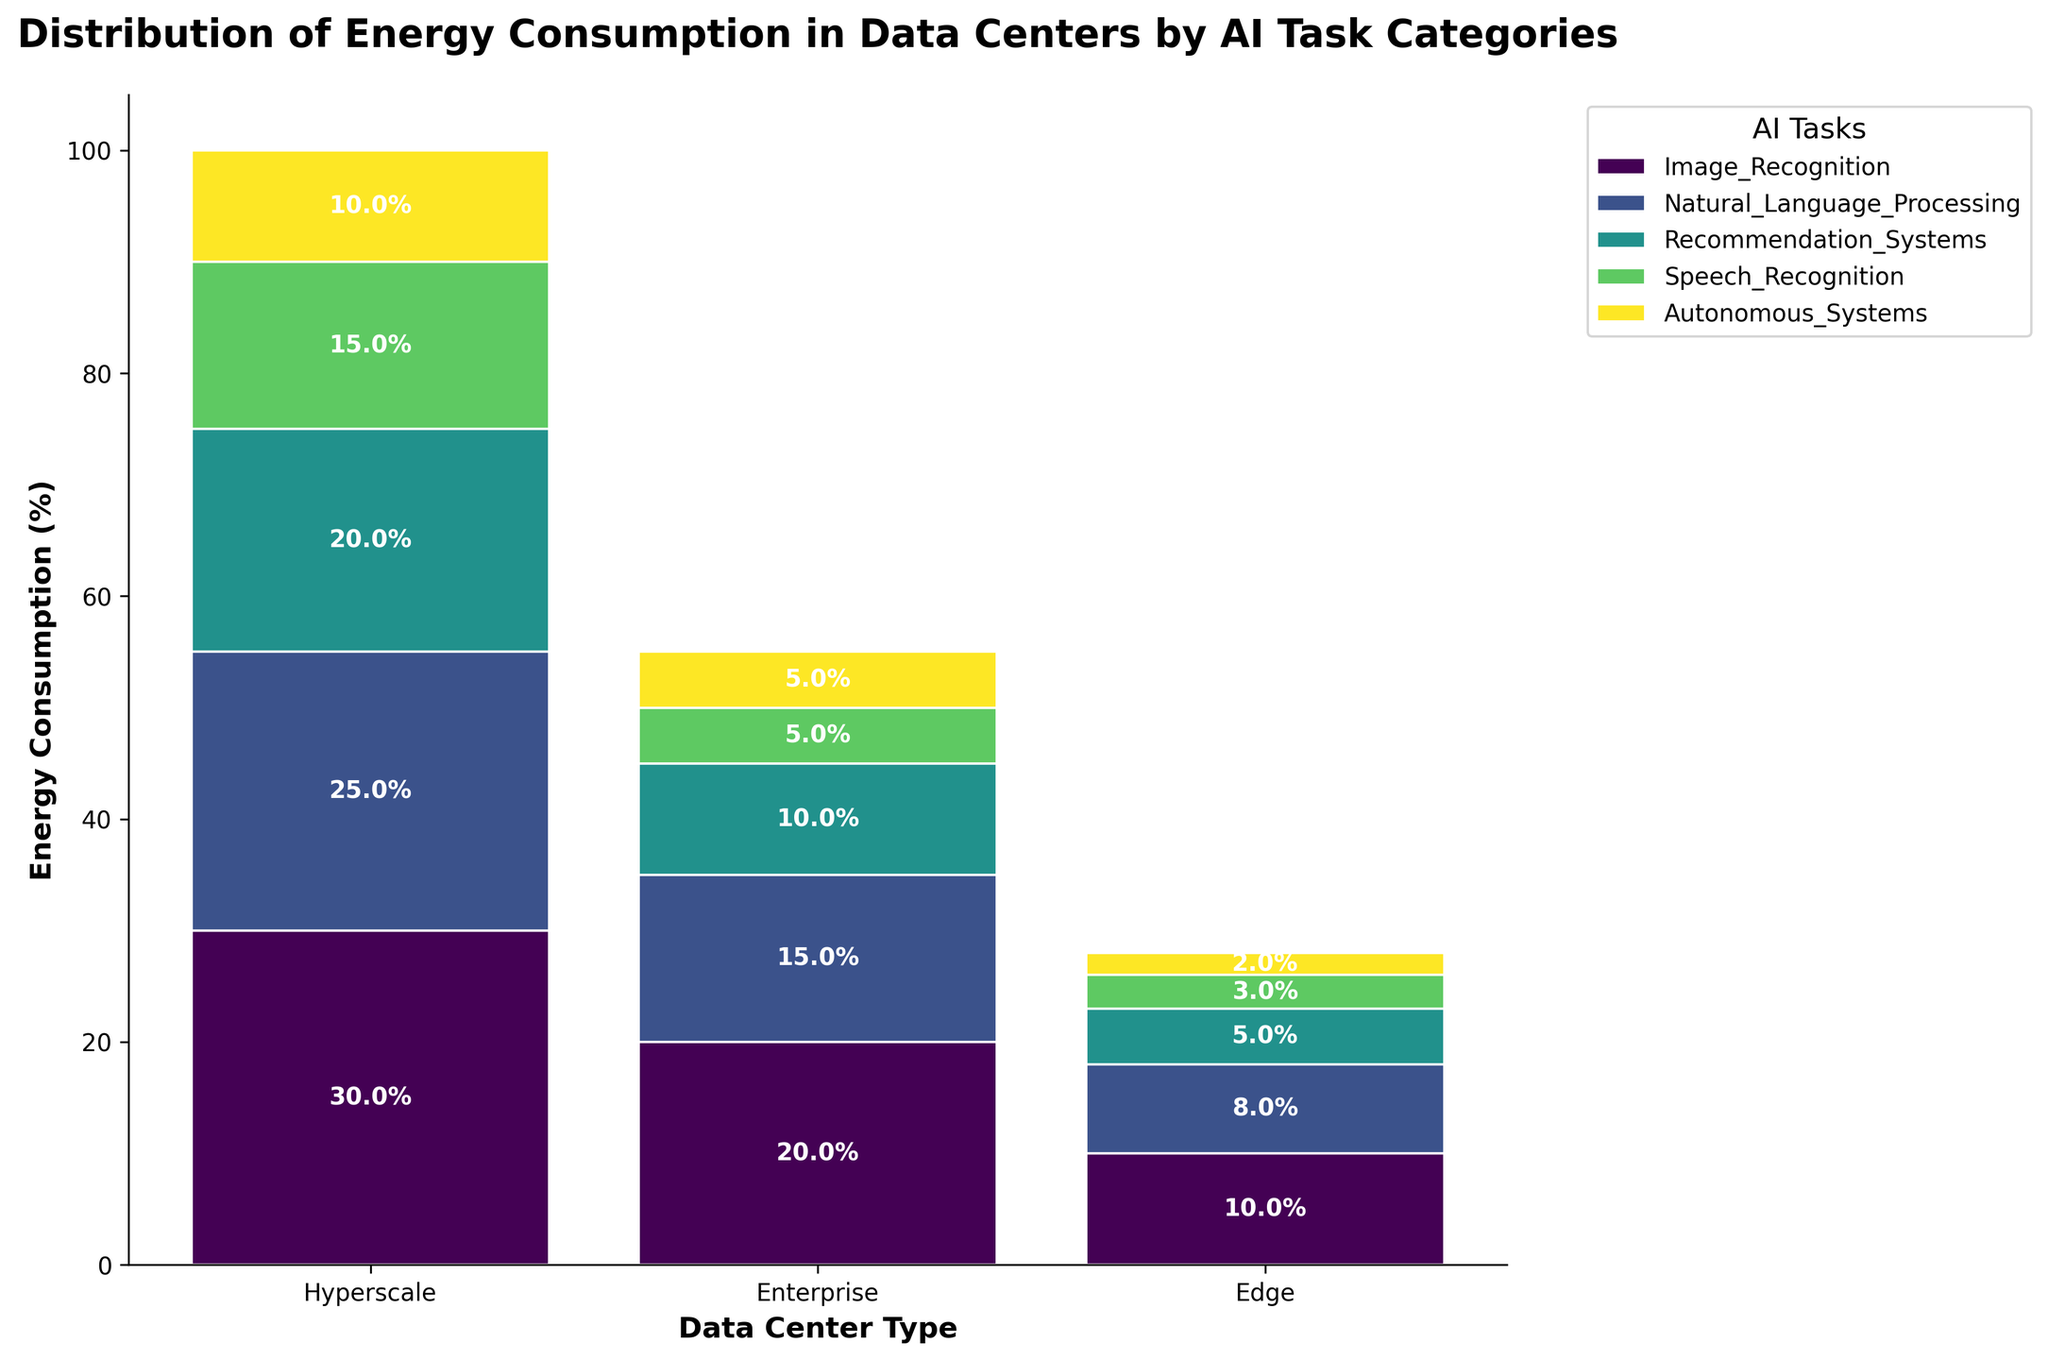What is the title of the figure? The title of the figure is located at the top and it summarizes what the plot is about. By reading it directly from the plot, we can see that it states "Distribution of Energy Consumption in Data Centers by AI Task Categories."
Answer: Distribution of Energy Consumption in Data Centers by AI Task Categories Which AI task has the highest energy consumption in Hyperscale data centers? To determine the AI task with the highest energy consumption in Hyperscale data centers, look at the tallest bar segment within the "Hyperscale" category. The tallest segment is for Image Recognition, which has a height of 30%.
Answer: Image Recognition How does the energy consumption for Autonomous Systems compare across the three types of data centers? To compare the energy consumption of Autonomous Systems across different data centers, check the height of the segments representing Autonomous Systems (identified by their consistent color) in each data center type. The energies are 10% for Hyperscale, 5% for Enterprise, and 2% for Edge data centers.
Answer: Highest in Hyperscale, followed by Enterprise, then Edge What is the total energy consumption percentage of all AI tasks in Enterprise data centers? Sum up the heights of all segments within the Enterprise data center category. These are 20% (Image Recognition) + 15% (Natural Language Processing) + 10% (Recommendation Systems) + 5% (Speech Recognition) + 5% (Autonomous Systems) which totals to 55%.
Answer: 55% Which AI tasks have around the same energy consumption across all three types of data centers? Look for AI tasks whose bar segments have similar heights across the Hyperscale, Enterprise, and Edge data centers. Speech Recognition has values of 15% in Hyperscale, 5% in Enterprise, and 3% in Edge which are relatively low but similar proportions.
Answer: Speech Recognition What is the difference in energy consumption between Recommendation Systems and Natural Language Processing in Hyperscale data centers? Find the bar segments for these two AI tasks within the Hyperscale category. Recommendation Systems consumes 20% while Natural Language Processing consumes 25%. The difference is 25% - 20% which equals 5%.
Answer: 5% Among Hyperscale, Enterprise, and Edge data centers, which type has the lowest total energy consumption for AI tasks? To identify the data center type with the lowest total energy consumption, sum up the heights of the energy consumption percentages for each type. Hyperscale: 100%, Enterprise: 55%, Edge: 28%. The Edge data center has the lowest total energy consumption.
Answer: Edge What is the combined energy consumption percentage for Image Recognition and Natural Language Processing in Edge data centers? Add the heights for the Image Recognition (10%) and Natural Language Processing (8%) segments in the Edge category. 10% + 8% = 18%.
Answer: 18% In which data center type does Recommendation Systems consume more energy compared to Autonomous Systems? Compare the heights of the segments for Recommendation Systems and Autonomous Systems within each data center type. They are higher for Recommendation Systems in all data center types: Hyperscale (20% vs. 10%), Enterprise (10% vs. 5%), Edge (5% vs. 2%).
Answer: In all data center types Which AI task consumes exactly the same amount of energy in both Hyperscale and Enterprise data centers? Compare the heights of the segments for each AI task across Hyperscale and Enterprise categories to find if any two match. Image Recognition is 30% in Hyperscale and 20% in Enterprise. None of the tasks consume the exact same in these two data centers.
Answer: None 